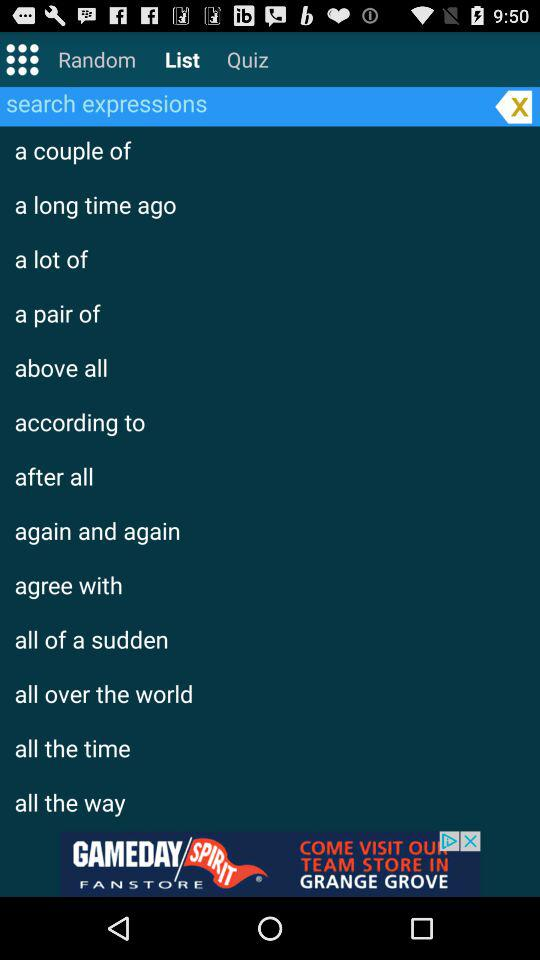What are the items in the search expressions? The items in the search expressions are "a couple of", "a long time ago", "a lot of", "a pair of", "above all", "according to", "after all", "again and again", "agree with", "all of a sudden", "all over the world", "all the time" and "all the way". 